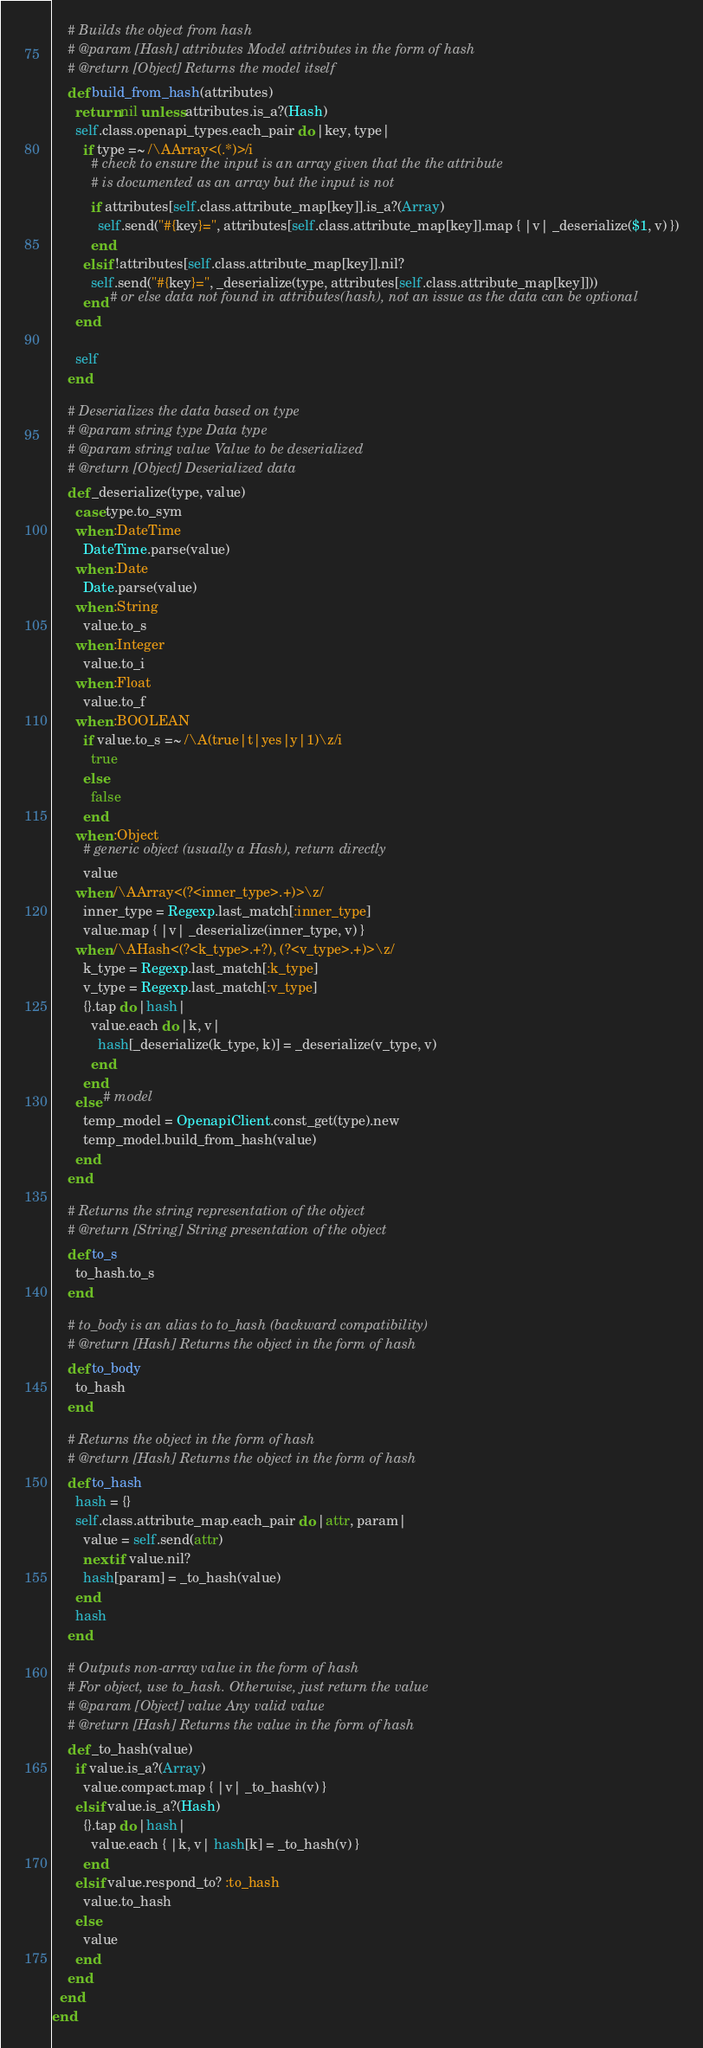Convert code to text. <code><loc_0><loc_0><loc_500><loc_500><_Ruby_>    # Builds the object from hash
    # @param [Hash] attributes Model attributes in the form of hash
    # @return [Object] Returns the model itself
    def build_from_hash(attributes)
      return nil unless attributes.is_a?(Hash)
      self.class.openapi_types.each_pair do |key, type|
        if type =~ /\AArray<(.*)>/i
          # check to ensure the input is an array given that the the attribute
          # is documented as an array but the input is not
          if attributes[self.class.attribute_map[key]].is_a?(Array)
            self.send("#{key}=", attributes[self.class.attribute_map[key]].map { |v| _deserialize($1, v) })
          end
        elsif !attributes[self.class.attribute_map[key]].nil?
          self.send("#{key}=", _deserialize(type, attributes[self.class.attribute_map[key]]))
        end # or else data not found in attributes(hash), not an issue as the data can be optional
      end

      self
    end

    # Deserializes the data based on type
    # @param string type Data type
    # @param string value Value to be deserialized
    # @return [Object] Deserialized data
    def _deserialize(type, value)
      case type.to_sym
      when :DateTime
        DateTime.parse(value)
      when :Date
        Date.parse(value)
      when :String
        value.to_s
      when :Integer
        value.to_i
      when :Float
        value.to_f
      when :BOOLEAN
        if value.to_s =~ /\A(true|t|yes|y|1)\z/i
          true
        else
          false
        end
      when :Object
        # generic object (usually a Hash), return directly
        value
      when /\AArray<(?<inner_type>.+)>\z/
        inner_type = Regexp.last_match[:inner_type]
        value.map { |v| _deserialize(inner_type, v) }
      when /\AHash<(?<k_type>.+?), (?<v_type>.+)>\z/
        k_type = Regexp.last_match[:k_type]
        v_type = Regexp.last_match[:v_type]
        {}.tap do |hash|
          value.each do |k, v|
            hash[_deserialize(k_type, k)] = _deserialize(v_type, v)
          end
        end
      else # model
        temp_model = OpenapiClient.const_get(type).new
        temp_model.build_from_hash(value)
      end
    end

    # Returns the string representation of the object
    # @return [String] String presentation of the object
    def to_s
      to_hash.to_s
    end

    # to_body is an alias to to_hash (backward compatibility)
    # @return [Hash] Returns the object in the form of hash
    def to_body
      to_hash
    end

    # Returns the object in the form of hash
    # @return [Hash] Returns the object in the form of hash
    def to_hash
      hash = {}
      self.class.attribute_map.each_pair do |attr, param|
        value = self.send(attr)
        next if value.nil?
        hash[param] = _to_hash(value)
      end
      hash
    end

    # Outputs non-array value in the form of hash
    # For object, use to_hash. Otherwise, just return the value
    # @param [Object] value Any valid value
    # @return [Hash] Returns the value in the form of hash
    def _to_hash(value)
      if value.is_a?(Array)
        value.compact.map { |v| _to_hash(v) }
      elsif value.is_a?(Hash)
        {}.tap do |hash|
          value.each { |k, v| hash[k] = _to_hash(v) }
        end
      elsif value.respond_to? :to_hash
        value.to_hash
      else
        value
      end
    end
  end
end
</code> 